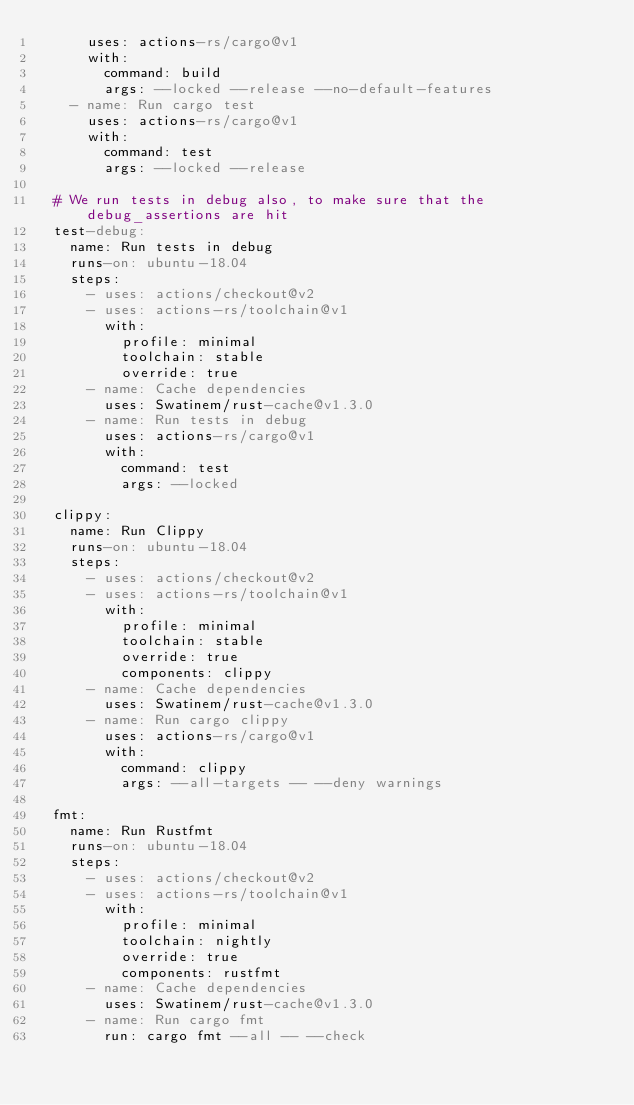<code> <loc_0><loc_0><loc_500><loc_500><_YAML_>      uses: actions-rs/cargo@v1
      with:
        command: build
        args: --locked --release --no-default-features
    - name: Run cargo test
      uses: actions-rs/cargo@v1
      with:
        command: test
        args: --locked --release

  # We run tests in debug also, to make sure that the debug_assertions are hit
  test-debug:
    name: Run tests in debug
    runs-on: ubuntu-18.04
    steps:
      - uses: actions/checkout@v2
      - uses: actions-rs/toolchain@v1
        with:
          profile: minimal
          toolchain: stable
          override: true
      - name: Cache dependencies
        uses: Swatinem/rust-cache@v1.3.0
      - name: Run tests in debug
        uses: actions-rs/cargo@v1
        with:
          command: test
          args: --locked

  clippy:
    name: Run Clippy
    runs-on: ubuntu-18.04
    steps:
      - uses: actions/checkout@v2
      - uses: actions-rs/toolchain@v1
        with:
          profile: minimal
          toolchain: stable
          override: true
          components: clippy
      - name: Cache dependencies
        uses: Swatinem/rust-cache@v1.3.0
      - name: Run cargo clippy
        uses: actions-rs/cargo@v1
        with:
          command: clippy
          args: --all-targets -- --deny warnings

  fmt:
    name: Run Rustfmt
    runs-on: ubuntu-18.04
    steps:
      - uses: actions/checkout@v2
      - uses: actions-rs/toolchain@v1
        with:
          profile: minimal
          toolchain: nightly
          override: true
          components: rustfmt
      - name: Cache dependencies
        uses: Swatinem/rust-cache@v1.3.0
      - name: Run cargo fmt
        run: cargo fmt --all -- --check
</code> 